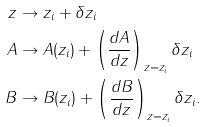<formula> <loc_0><loc_0><loc_500><loc_500>z & \rightarrow z _ { i } + \delta z _ { i } \\ A & \rightarrow A ( z _ { i } ) + \left ( \frac { d A } { d z } \right ) _ { z = z _ { i } } \delta z _ { i } \\ B & \rightarrow B ( z _ { i } ) + \left ( \frac { d B } { d z } \right ) _ { z = z _ { i } } \delta z _ { i } .</formula> 